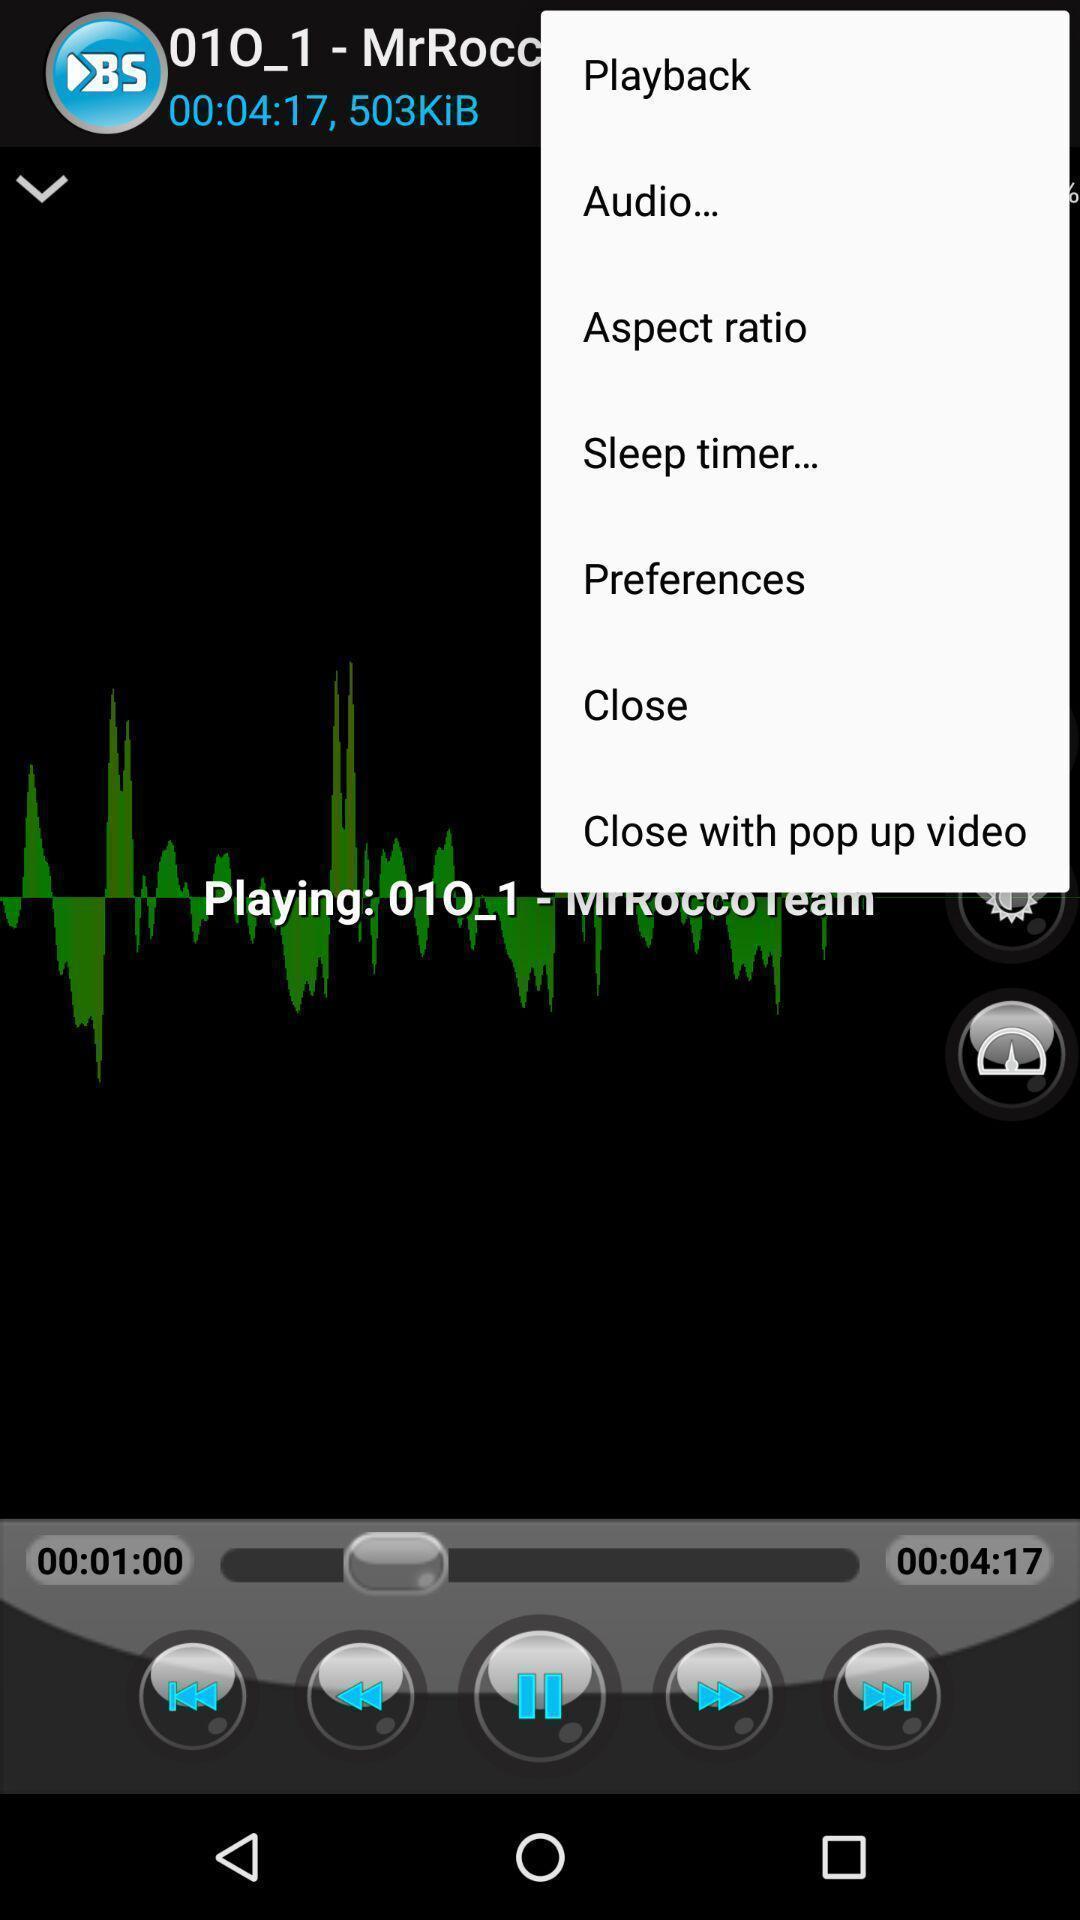Provide a description of this screenshot. Push up notification displayed playback and other options. 